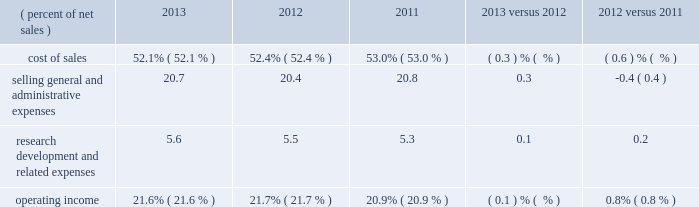Operating expenses : 2013 versus 2012 versus ( percent of net sales ) 2013 2012 2011 .
Pension and postretirement expense decreased $ 97 million in 2013 compared to 2012 , compared to an increase of $ 95 million for 2012 compared to 2011 .
2012 includes a $ 26 million charge related to the first-quarter 2012 voluntary early retirement incentive program ( discussed in note 10 ) .
Pension and postretirement expense is recorded in cost of sales ; selling , general and administrative expenses ( sg&a ) ; and research , development and related expenses ( r&d ) .
Refer to note 10 ( pension and postretirement plans ) for components of net periodic benefit cost and the assumptions used to determine net cost .
Cost of sales : cost of sales includes manufacturing , engineering and freight costs .
Cost of sales , measured as a percent of net sales , was 52.1 percent in 2013 , a decrease of 0.3 percentage points from 2012 .
Cost of sales as a percent of sales decreased due to the combination of selling price increases and raw material cost decreases , as selling prices rose 0.9 percent and raw material cost deflation was approximately 2 percent favorable year-on-year .
In addition , lower pension and postretirement costs ( of which a portion impacts cost of sales ) , in addition to organic volume increases , decreased cost of sales as a percent of sales .
These benefits were partially offset by the impact of 2012 acquisitions and lower factory utilization .
Cost of sales , measured as a percent of net sales , was 52.4 percent in 2012 , a decrease of 0.6 percentage points from 2011 .
The net impact of selling price/raw material cost changes was the primary factor that decreased cost of sales as a percent of sales , as selling prices increased 1.4 percent and raw material costs decreased approximately 2 percent .
This benefit was partially offset by higher pension and postretirement costs .
Selling , general and administrative expenses : selling , general and administrative expenses ( sg&a ) increased $ 282 million , or 4.6 percent , in 2013 when compared to 2012 .
In 2013 , sg&a included strategic investments in business transformation , enabled by 3m 2019s global enterprise resource planning ( erp ) implementation , in addition to increases from acquired businesses that were largely not in 3m 2019s 2012 spending ( ceradyne , inc .
And federal signal technologies ) , which were partially offset by lower pension and postretirement expense .
Sg&a , measured as a percent of sales , increased 0.3 percentage points to 20.7 percent in 2013 , compared to 20.4 percent in 2012 .
Sg&a decreased $ 68 million , or 1.1 percent , in 2012 when compared to 2011 .
In addition to cost-control and other productivity efforts , 3m experienced some savings from its first-quarter 2012 voluntary early retirement incentive program and other restructuring actions .
These benefits more than offset increases related to acquisitions , higher year-on-year pension and postretirement expense , and restructuring expenses .
Sg&a in 2012 included increases from acquired businesses which were not in 3m 2019s full-year 2011 base spending , primarily related to the 2011 acquisitions of winterthur technologie ag and the do-it-yourself and professional business of gpi group , in addition to sg&a spending related to the 2012 acquisitions of ceradyne , inc. , federal signal technologies group , and coderyte , inc .
Sg&a , measured as a percent of sales , was 20.4 percent in 2012 , a decrease of 0.4 percentage points when compared to 2011 .
Research , development and related expenses : research , development and related expenses ( r&d ) increased 4.9 percent in 2013 compared to 2012 and increased 4.1 percent in 2012 compared to 2011 , as 3m continued to support its key growth initiatives , including more r&d aimed at disruptive innovation .
In 2013 , increases from acquired businesses that were largely not in 3m 2019s 2012 spending ( primarily ceradyne , inc .
And federal signal technologies ) were partially offset by lower pension and postretirement expense .
In 2012 , investments to support key growth initiatives , along with higher pension and postretirement expense , were partially .
In 2012 what was the percent of the voluntary early retirement incentive program to the increase in the pension and postretirement expense? 
Computations: (26 / 95)
Answer: 0.27368. 